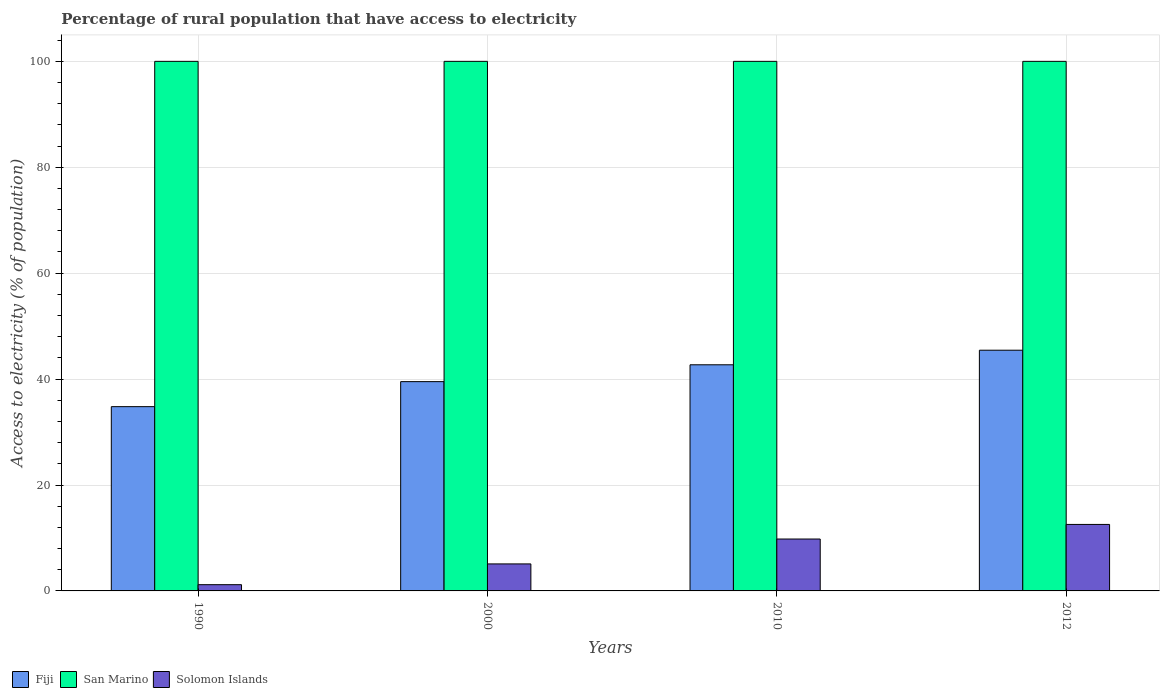How many groups of bars are there?
Make the answer very short. 4. Are the number of bars per tick equal to the number of legend labels?
Provide a short and direct response. Yes. How many bars are there on the 3rd tick from the left?
Your answer should be very brief. 3. In how many cases, is the number of bars for a given year not equal to the number of legend labels?
Your answer should be compact. 0. What is the percentage of rural population that have access to electricity in Fiji in 1990?
Give a very brief answer. 34.8. Across all years, what is the maximum percentage of rural population that have access to electricity in Solomon Islands?
Ensure brevity in your answer.  12.55. Across all years, what is the minimum percentage of rural population that have access to electricity in San Marino?
Your response must be concise. 100. In which year was the percentage of rural population that have access to electricity in Fiji maximum?
Keep it short and to the point. 2012. What is the total percentage of rural population that have access to electricity in Fiji in the graph?
Your answer should be very brief. 162.47. What is the difference between the percentage of rural population that have access to electricity in Fiji in 2000 and the percentage of rural population that have access to electricity in Solomon Islands in 1990?
Provide a succinct answer. 38.34. In the year 2012, what is the difference between the percentage of rural population that have access to electricity in Solomon Islands and percentage of rural population that have access to electricity in San Marino?
Keep it short and to the point. -87.45. What is the ratio of the percentage of rural population that have access to electricity in San Marino in 1990 to that in 2010?
Offer a terse response. 1. Is the percentage of rural population that have access to electricity in San Marino in 2000 less than that in 2012?
Offer a very short reply. No. Is the difference between the percentage of rural population that have access to electricity in Solomon Islands in 2000 and 2012 greater than the difference between the percentage of rural population that have access to electricity in San Marino in 2000 and 2012?
Provide a short and direct response. No. What is the difference between the highest and the second highest percentage of rural population that have access to electricity in Solomon Islands?
Keep it short and to the point. 2.75. What is the difference between the highest and the lowest percentage of rural population that have access to electricity in San Marino?
Offer a very short reply. 0. Is the sum of the percentage of rural population that have access to electricity in San Marino in 2010 and 2012 greater than the maximum percentage of rural population that have access to electricity in Fiji across all years?
Provide a succinct answer. Yes. What does the 3rd bar from the left in 2000 represents?
Provide a succinct answer. Solomon Islands. What does the 1st bar from the right in 2012 represents?
Your answer should be compact. Solomon Islands. How many years are there in the graph?
Your answer should be very brief. 4. What is the difference between two consecutive major ticks on the Y-axis?
Your answer should be compact. 20. Does the graph contain any zero values?
Give a very brief answer. No. How many legend labels are there?
Your answer should be compact. 3. What is the title of the graph?
Keep it short and to the point. Percentage of rural population that have access to electricity. Does "Timor-Leste" appear as one of the legend labels in the graph?
Your answer should be compact. No. What is the label or title of the Y-axis?
Offer a terse response. Access to electricity (% of population). What is the Access to electricity (% of population) in Fiji in 1990?
Provide a succinct answer. 34.8. What is the Access to electricity (% of population) of Solomon Islands in 1990?
Offer a very short reply. 1.18. What is the Access to electricity (% of population) in Fiji in 2000?
Your answer should be compact. 39.52. What is the Access to electricity (% of population) of San Marino in 2000?
Make the answer very short. 100. What is the Access to electricity (% of population) in Fiji in 2010?
Ensure brevity in your answer.  42.7. What is the Access to electricity (% of population) of San Marino in 2010?
Offer a terse response. 100. What is the Access to electricity (% of population) in Fiji in 2012?
Give a very brief answer. 45.45. What is the Access to electricity (% of population) in Solomon Islands in 2012?
Your response must be concise. 12.55. Across all years, what is the maximum Access to electricity (% of population) of Fiji?
Provide a succinct answer. 45.45. Across all years, what is the maximum Access to electricity (% of population) in Solomon Islands?
Your answer should be compact. 12.55. Across all years, what is the minimum Access to electricity (% of population) of Fiji?
Provide a short and direct response. 34.8. Across all years, what is the minimum Access to electricity (% of population) of Solomon Islands?
Keep it short and to the point. 1.18. What is the total Access to electricity (% of population) of Fiji in the graph?
Ensure brevity in your answer.  162.47. What is the total Access to electricity (% of population) in San Marino in the graph?
Your answer should be very brief. 400. What is the total Access to electricity (% of population) of Solomon Islands in the graph?
Give a very brief answer. 28.63. What is the difference between the Access to electricity (% of population) of Fiji in 1990 and that in 2000?
Your answer should be very brief. -4.72. What is the difference between the Access to electricity (% of population) of Solomon Islands in 1990 and that in 2000?
Your response must be concise. -3.92. What is the difference between the Access to electricity (% of population) of Fiji in 1990 and that in 2010?
Make the answer very short. -7.9. What is the difference between the Access to electricity (% of population) of Solomon Islands in 1990 and that in 2010?
Keep it short and to the point. -8.62. What is the difference between the Access to electricity (% of population) of Fiji in 1990 and that in 2012?
Your answer should be compact. -10.66. What is the difference between the Access to electricity (% of population) of San Marino in 1990 and that in 2012?
Give a very brief answer. 0. What is the difference between the Access to electricity (% of population) of Solomon Islands in 1990 and that in 2012?
Offer a terse response. -11.38. What is the difference between the Access to electricity (% of population) of Fiji in 2000 and that in 2010?
Make the answer very short. -3.18. What is the difference between the Access to electricity (% of population) in San Marino in 2000 and that in 2010?
Make the answer very short. 0. What is the difference between the Access to electricity (% of population) in Fiji in 2000 and that in 2012?
Ensure brevity in your answer.  -5.93. What is the difference between the Access to electricity (% of population) in San Marino in 2000 and that in 2012?
Offer a very short reply. 0. What is the difference between the Access to electricity (% of population) of Solomon Islands in 2000 and that in 2012?
Give a very brief answer. -7.45. What is the difference between the Access to electricity (% of population) of Fiji in 2010 and that in 2012?
Offer a terse response. -2.75. What is the difference between the Access to electricity (% of population) in San Marino in 2010 and that in 2012?
Ensure brevity in your answer.  0. What is the difference between the Access to electricity (% of population) of Solomon Islands in 2010 and that in 2012?
Your answer should be compact. -2.75. What is the difference between the Access to electricity (% of population) in Fiji in 1990 and the Access to electricity (% of population) in San Marino in 2000?
Offer a terse response. -65.2. What is the difference between the Access to electricity (% of population) in Fiji in 1990 and the Access to electricity (% of population) in Solomon Islands in 2000?
Offer a terse response. 29.7. What is the difference between the Access to electricity (% of population) of San Marino in 1990 and the Access to electricity (% of population) of Solomon Islands in 2000?
Offer a very short reply. 94.9. What is the difference between the Access to electricity (% of population) of Fiji in 1990 and the Access to electricity (% of population) of San Marino in 2010?
Offer a terse response. -65.2. What is the difference between the Access to electricity (% of population) of Fiji in 1990 and the Access to electricity (% of population) of Solomon Islands in 2010?
Offer a very short reply. 25. What is the difference between the Access to electricity (% of population) in San Marino in 1990 and the Access to electricity (% of population) in Solomon Islands in 2010?
Ensure brevity in your answer.  90.2. What is the difference between the Access to electricity (% of population) of Fiji in 1990 and the Access to electricity (% of population) of San Marino in 2012?
Give a very brief answer. -65.2. What is the difference between the Access to electricity (% of population) in Fiji in 1990 and the Access to electricity (% of population) in Solomon Islands in 2012?
Make the answer very short. 22.24. What is the difference between the Access to electricity (% of population) in San Marino in 1990 and the Access to electricity (% of population) in Solomon Islands in 2012?
Keep it short and to the point. 87.45. What is the difference between the Access to electricity (% of population) in Fiji in 2000 and the Access to electricity (% of population) in San Marino in 2010?
Your response must be concise. -60.48. What is the difference between the Access to electricity (% of population) of Fiji in 2000 and the Access to electricity (% of population) of Solomon Islands in 2010?
Your answer should be very brief. 29.72. What is the difference between the Access to electricity (% of population) of San Marino in 2000 and the Access to electricity (% of population) of Solomon Islands in 2010?
Make the answer very short. 90.2. What is the difference between the Access to electricity (% of population) in Fiji in 2000 and the Access to electricity (% of population) in San Marino in 2012?
Ensure brevity in your answer.  -60.48. What is the difference between the Access to electricity (% of population) in Fiji in 2000 and the Access to electricity (% of population) in Solomon Islands in 2012?
Ensure brevity in your answer.  26.97. What is the difference between the Access to electricity (% of population) of San Marino in 2000 and the Access to electricity (% of population) of Solomon Islands in 2012?
Make the answer very short. 87.45. What is the difference between the Access to electricity (% of population) in Fiji in 2010 and the Access to electricity (% of population) in San Marino in 2012?
Your answer should be very brief. -57.3. What is the difference between the Access to electricity (% of population) of Fiji in 2010 and the Access to electricity (% of population) of Solomon Islands in 2012?
Give a very brief answer. 30.15. What is the difference between the Access to electricity (% of population) in San Marino in 2010 and the Access to electricity (% of population) in Solomon Islands in 2012?
Give a very brief answer. 87.45. What is the average Access to electricity (% of population) of Fiji per year?
Your answer should be compact. 40.62. What is the average Access to electricity (% of population) of Solomon Islands per year?
Ensure brevity in your answer.  7.16. In the year 1990, what is the difference between the Access to electricity (% of population) of Fiji and Access to electricity (% of population) of San Marino?
Your answer should be very brief. -65.2. In the year 1990, what is the difference between the Access to electricity (% of population) in Fiji and Access to electricity (% of population) in Solomon Islands?
Give a very brief answer. 33.62. In the year 1990, what is the difference between the Access to electricity (% of population) of San Marino and Access to electricity (% of population) of Solomon Islands?
Ensure brevity in your answer.  98.82. In the year 2000, what is the difference between the Access to electricity (% of population) of Fiji and Access to electricity (% of population) of San Marino?
Your answer should be very brief. -60.48. In the year 2000, what is the difference between the Access to electricity (% of population) of Fiji and Access to electricity (% of population) of Solomon Islands?
Provide a succinct answer. 34.42. In the year 2000, what is the difference between the Access to electricity (% of population) in San Marino and Access to electricity (% of population) in Solomon Islands?
Offer a terse response. 94.9. In the year 2010, what is the difference between the Access to electricity (% of population) in Fiji and Access to electricity (% of population) in San Marino?
Provide a short and direct response. -57.3. In the year 2010, what is the difference between the Access to electricity (% of population) of Fiji and Access to electricity (% of population) of Solomon Islands?
Provide a short and direct response. 32.9. In the year 2010, what is the difference between the Access to electricity (% of population) of San Marino and Access to electricity (% of population) of Solomon Islands?
Your answer should be compact. 90.2. In the year 2012, what is the difference between the Access to electricity (% of population) in Fiji and Access to electricity (% of population) in San Marino?
Offer a terse response. -54.55. In the year 2012, what is the difference between the Access to electricity (% of population) in Fiji and Access to electricity (% of population) in Solomon Islands?
Provide a short and direct response. 32.9. In the year 2012, what is the difference between the Access to electricity (% of population) of San Marino and Access to electricity (% of population) of Solomon Islands?
Your answer should be very brief. 87.45. What is the ratio of the Access to electricity (% of population) in Fiji in 1990 to that in 2000?
Offer a terse response. 0.88. What is the ratio of the Access to electricity (% of population) in Solomon Islands in 1990 to that in 2000?
Your answer should be very brief. 0.23. What is the ratio of the Access to electricity (% of population) of Fiji in 1990 to that in 2010?
Make the answer very short. 0.81. What is the ratio of the Access to electricity (% of population) of Solomon Islands in 1990 to that in 2010?
Keep it short and to the point. 0.12. What is the ratio of the Access to electricity (% of population) of Fiji in 1990 to that in 2012?
Keep it short and to the point. 0.77. What is the ratio of the Access to electricity (% of population) in Solomon Islands in 1990 to that in 2012?
Offer a terse response. 0.09. What is the ratio of the Access to electricity (% of population) in Fiji in 2000 to that in 2010?
Make the answer very short. 0.93. What is the ratio of the Access to electricity (% of population) of Solomon Islands in 2000 to that in 2010?
Provide a short and direct response. 0.52. What is the ratio of the Access to electricity (% of population) in Fiji in 2000 to that in 2012?
Give a very brief answer. 0.87. What is the ratio of the Access to electricity (% of population) of Solomon Islands in 2000 to that in 2012?
Your response must be concise. 0.41. What is the ratio of the Access to electricity (% of population) of Fiji in 2010 to that in 2012?
Your answer should be compact. 0.94. What is the ratio of the Access to electricity (% of population) in San Marino in 2010 to that in 2012?
Your answer should be very brief. 1. What is the ratio of the Access to electricity (% of population) in Solomon Islands in 2010 to that in 2012?
Your answer should be very brief. 0.78. What is the difference between the highest and the second highest Access to electricity (% of population) in Fiji?
Keep it short and to the point. 2.75. What is the difference between the highest and the second highest Access to electricity (% of population) of San Marino?
Provide a short and direct response. 0. What is the difference between the highest and the second highest Access to electricity (% of population) of Solomon Islands?
Provide a short and direct response. 2.75. What is the difference between the highest and the lowest Access to electricity (% of population) of Fiji?
Keep it short and to the point. 10.66. What is the difference between the highest and the lowest Access to electricity (% of population) of Solomon Islands?
Offer a terse response. 11.38. 